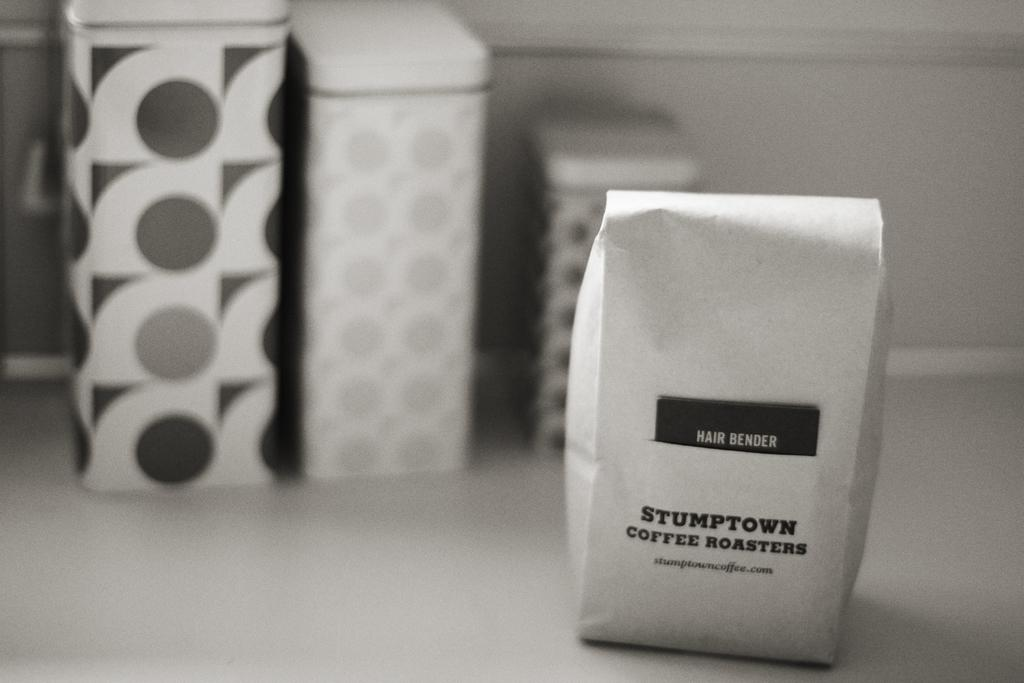<image>
Provide a brief description of the given image. A black and white image of a bag of Stumptown coffee sitting before three cannisters. 